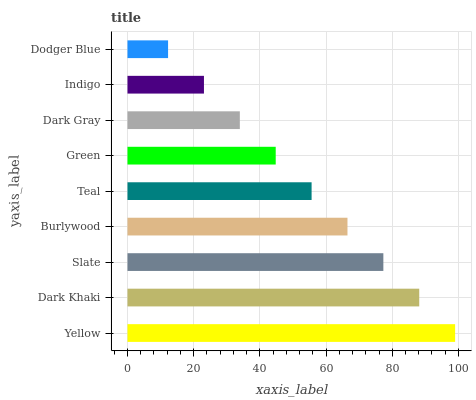Is Dodger Blue the minimum?
Answer yes or no. Yes. Is Yellow the maximum?
Answer yes or no. Yes. Is Dark Khaki the minimum?
Answer yes or no. No. Is Dark Khaki the maximum?
Answer yes or no. No. Is Yellow greater than Dark Khaki?
Answer yes or no. Yes. Is Dark Khaki less than Yellow?
Answer yes or no. Yes. Is Dark Khaki greater than Yellow?
Answer yes or no. No. Is Yellow less than Dark Khaki?
Answer yes or no. No. Is Teal the high median?
Answer yes or no. Yes. Is Teal the low median?
Answer yes or no. Yes. Is Yellow the high median?
Answer yes or no. No. Is Dodger Blue the low median?
Answer yes or no. No. 